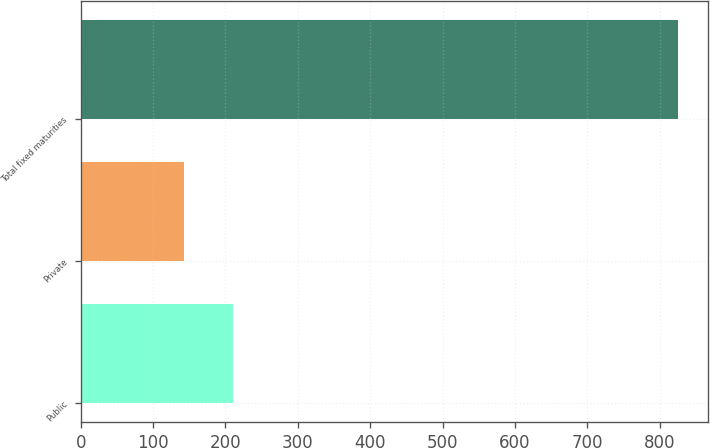Convert chart. <chart><loc_0><loc_0><loc_500><loc_500><bar_chart><fcel>Public<fcel>Private<fcel>Total fixed maturities<nl><fcel>211<fcel>142.7<fcel>825.7<nl></chart> 